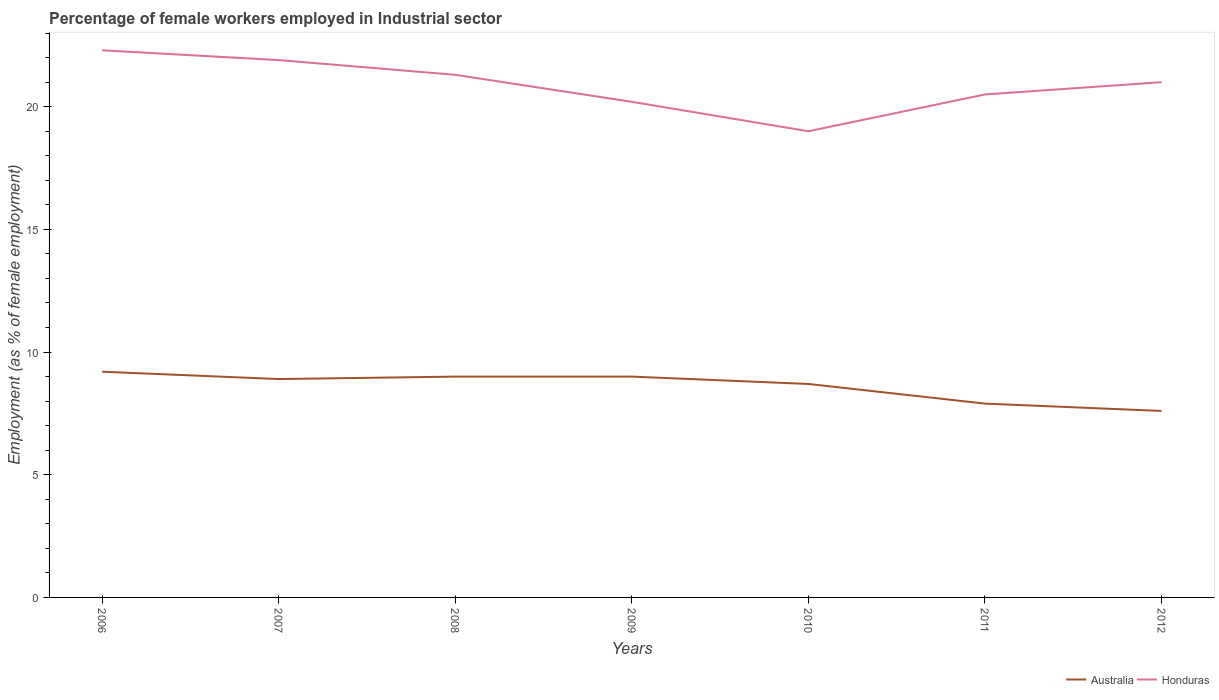How many different coloured lines are there?
Your response must be concise. 2. Across all years, what is the maximum percentage of females employed in Industrial sector in Honduras?
Offer a very short reply. 19. What is the total percentage of females employed in Industrial sector in Australia in the graph?
Keep it short and to the point. 0.2. What is the difference between the highest and the second highest percentage of females employed in Industrial sector in Australia?
Provide a succinct answer. 1.6. What is the difference between the highest and the lowest percentage of females employed in Industrial sector in Australia?
Keep it short and to the point. 5. Is the percentage of females employed in Industrial sector in Honduras strictly greater than the percentage of females employed in Industrial sector in Australia over the years?
Your response must be concise. No. Are the values on the major ticks of Y-axis written in scientific E-notation?
Make the answer very short. No. Does the graph contain any zero values?
Your answer should be compact. No. How many legend labels are there?
Your answer should be compact. 2. How are the legend labels stacked?
Provide a succinct answer. Horizontal. What is the title of the graph?
Offer a terse response. Percentage of female workers employed in Industrial sector. Does "Lithuania" appear as one of the legend labels in the graph?
Ensure brevity in your answer.  No. What is the label or title of the Y-axis?
Provide a short and direct response. Employment (as % of female employment). What is the Employment (as % of female employment) in Australia in 2006?
Keep it short and to the point. 9.2. What is the Employment (as % of female employment) in Honduras in 2006?
Give a very brief answer. 22.3. What is the Employment (as % of female employment) in Australia in 2007?
Offer a terse response. 8.9. What is the Employment (as % of female employment) in Honduras in 2007?
Make the answer very short. 21.9. What is the Employment (as % of female employment) of Australia in 2008?
Make the answer very short. 9. What is the Employment (as % of female employment) in Honduras in 2008?
Keep it short and to the point. 21.3. What is the Employment (as % of female employment) in Australia in 2009?
Ensure brevity in your answer.  9. What is the Employment (as % of female employment) in Honduras in 2009?
Ensure brevity in your answer.  20.2. What is the Employment (as % of female employment) of Australia in 2010?
Give a very brief answer. 8.7. What is the Employment (as % of female employment) of Australia in 2011?
Your answer should be compact. 7.9. What is the Employment (as % of female employment) of Australia in 2012?
Offer a terse response. 7.6. Across all years, what is the maximum Employment (as % of female employment) of Australia?
Your answer should be compact. 9.2. Across all years, what is the maximum Employment (as % of female employment) in Honduras?
Make the answer very short. 22.3. Across all years, what is the minimum Employment (as % of female employment) in Australia?
Your answer should be very brief. 7.6. What is the total Employment (as % of female employment) of Australia in the graph?
Offer a very short reply. 60.3. What is the total Employment (as % of female employment) in Honduras in the graph?
Your answer should be compact. 146.2. What is the difference between the Employment (as % of female employment) of Australia in 2006 and that in 2007?
Provide a short and direct response. 0.3. What is the difference between the Employment (as % of female employment) in Honduras in 2006 and that in 2007?
Ensure brevity in your answer.  0.4. What is the difference between the Employment (as % of female employment) of Australia in 2006 and that in 2008?
Make the answer very short. 0.2. What is the difference between the Employment (as % of female employment) in Australia in 2006 and that in 2009?
Keep it short and to the point. 0.2. What is the difference between the Employment (as % of female employment) in Honduras in 2006 and that in 2009?
Make the answer very short. 2.1. What is the difference between the Employment (as % of female employment) of Honduras in 2006 and that in 2010?
Provide a short and direct response. 3.3. What is the difference between the Employment (as % of female employment) of Australia in 2006 and that in 2011?
Provide a short and direct response. 1.3. What is the difference between the Employment (as % of female employment) in Honduras in 2006 and that in 2011?
Offer a terse response. 1.8. What is the difference between the Employment (as % of female employment) in Australia in 2006 and that in 2012?
Make the answer very short. 1.6. What is the difference between the Employment (as % of female employment) of Honduras in 2006 and that in 2012?
Offer a very short reply. 1.3. What is the difference between the Employment (as % of female employment) of Honduras in 2007 and that in 2008?
Give a very brief answer. 0.6. What is the difference between the Employment (as % of female employment) in Australia in 2007 and that in 2009?
Ensure brevity in your answer.  -0.1. What is the difference between the Employment (as % of female employment) in Australia in 2007 and that in 2010?
Your answer should be very brief. 0.2. What is the difference between the Employment (as % of female employment) of Honduras in 2007 and that in 2010?
Your answer should be compact. 2.9. What is the difference between the Employment (as % of female employment) in Australia in 2007 and that in 2011?
Provide a short and direct response. 1. What is the difference between the Employment (as % of female employment) in Australia in 2007 and that in 2012?
Ensure brevity in your answer.  1.3. What is the difference between the Employment (as % of female employment) of Honduras in 2007 and that in 2012?
Ensure brevity in your answer.  0.9. What is the difference between the Employment (as % of female employment) in Honduras in 2008 and that in 2010?
Provide a succinct answer. 2.3. What is the difference between the Employment (as % of female employment) of Australia in 2008 and that in 2012?
Your answer should be very brief. 1.4. What is the difference between the Employment (as % of female employment) in Honduras in 2009 and that in 2011?
Provide a short and direct response. -0.3. What is the difference between the Employment (as % of female employment) in Australia in 2009 and that in 2012?
Give a very brief answer. 1.4. What is the difference between the Employment (as % of female employment) of Honduras in 2010 and that in 2012?
Give a very brief answer. -2. What is the difference between the Employment (as % of female employment) in Honduras in 2011 and that in 2012?
Ensure brevity in your answer.  -0.5. What is the difference between the Employment (as % of female employment) of Australia in 2006 and the Employment (as % of female employment) of Honduras in 2007?
Your answer should be very brief. -12.7. What is the difference between the Employment (as % of female employment) of Australia in 2006 and the Employment (as % of female employment) of Honduras in 2008?
Give a very brief answer. -12.1. What is the difference between the Employment (as % of female employment) in Australia in 2006 and the Employment (as % of female employment) in Honduras in 2009?
Your answer should be compact. -11. What is the difference between the Employment (as % of female employment) in Australia in 2006 and the Employment (as % of female employment) in Honduras in 2011?
Keep it short and to the point. -11.3. What is the difference between the Employment (as % of female employment) of Australia in 2006 and the Employment (as % of female employment) of Honduras in 2012?
Keep it short and to the point. -11.8. What is the difference between the Employment (as % of female employment) of Australia in 2007 and the Employment (as % of female employment) of Honduras in 2010?
Offer a very short reply. -10.1. What is the difference between the Employment (as % of female employment) in Australia in 2007 and the Employment (as % of female employment) in Honduras in 2012?
Ensure brevity in your answer.  -12.1. What is the difference between the Employment (as % of female employment) in Australia in 2008 and the Employment (as % of female employment) in Honduras in 2009?
Keep it short and to the point. -11.2. What is the difference between the Employment (as % of female employment) in Australia in 2008 and the Employment (as % of female employment) in Honduras in 2010?
Keep it short and to the point. -10. What is the difference between the Employment (as % of female employment) of Australia in 2008 and the Employment (as % of female employment) of Honduras in 2012?
Offer a terse response. -12. What is the difference between the Employment (as % of female employment) in Australia in 2009 and the Employment (as % of female employment) in Honduras in 2010?
Keep it short and to the point. -10. What is the difference between the Employment (as % of female employment) in Australia in 2009 and the Employment (as % of female employment) in Honduras in 2012?
Ensure brevity in your answer.  -12. What is the difference between the Employment (as % of female employment) of Australia in 2010 and the Employment (as % of female employment) of Honduras in 2011?
Your answer should be compact. -11.8. What is the difference between the Employment (as % of female employment) of Australia in 2010 and the Employment (as % of female employment) of Honduras in 2012?
Keep it short and to the point. -12.3. What is the difference between the Employment (as % of female employment) in Australia in 2011 and the Employment (as % of female employment) in Honduras in 2012?
Your response must be concise. -13.1. What is the average Employment (as % of female employment) of Australia per year?
Offer a very short reply. 8.61. What is the average Employment (as % of female employment) in Honduras per year?
Provide a succinct answer. 20.89. In the year 2008, what is the difference between the Employment (as % of female employment) in Australia and Employment (as % of female employment) in Honduras?
Offer a very short reply. -12.3. In the year 2009, what is the difference between the Employment (as % of female employment) in Australia and Employment (as % of female employment) in Honduras?
Offer a terse response. -11.2. In the year 2010, what is the difference between the Employment (as % of female employment) in Australia and Employment (as % of female employment) in Honduras?
Give a very brief answer. -10.3. What is the ratio of the Employment (as % of female employment) of Australia in 2006 to that in 2007?
Make the answer very short. 1.03. What is the ratio of the Employment (as % of female employment) in Honduras in 2006 to that in 2007?
Your answer should be very brief. 1.02. What is the ratio of the Employment (as % of female employment) of Australia in 2006 to that in 2008?
Keep it short and to the point. 1.02. What is the ratio of the Employment (as % of female employment) of Honduras in 2006 to that in 2008?
Make the answer very short. 1.05. What is the ratio of the Employment (as % of female employment) of Australia in 2006 to that in 2009?
Keep it short and to the point. 1.02. What is the ratio of the Employment (as % of female employment) of Honduras in 2006 to that in 2009?
Offer a very short reply. 1.1. What is the ratio of the Employment (as % of female employment) of Australia in 2006 to that in 2010?
Give a very brief answer. 1.06. What is the ratio of the Employment (as % of female employment) of Honduras in 2006 to that in 2010?
Make the answer very short. 1.17. What is the ratio of the Employment (as % of female employment) of Australia in 2006 to that in 2011?
Provide a succinct answer. 1.16. What is the ratio of the Employment (as % of female employment) of Honduras in 2006 to that in 2011?
Your answer should be very brief. 1.09. What is the ratio of the Employment (as % of female employment) of Australia in 2006 to that in 2012?
Offer a terse response. 1.21. What is the ratio of the Employment (as % of female employment) of Honduras in 2006 to that in 2012?
Ensure brevity in your answer.  1.06. What is the ratio of the Employment (as % of female employment) in Australia in 2007 to that in 2008?
Give a very brief answer. 0.99. What is the ratio of the Employment (as % of female employment) in Honduras in 2007 to that in 2008?
Your response must be concise. 1.03. What is the ratio of the Employment (as % of female employment) of Australia in 2007 to that in 2009?
Your answer should be very brief. 0.99. What is the ratio of the Employment (as % of female employment) in Honduras in 2007 to that in 2009?
Ensure brevity in your answer.  1.08. What is the ratio of the Employment (as % of female employment) of Australia in 2007 to that in 2010?
Provide a short and direct response. 1.02. What is the ratio of the Employment (as % of female employment) of Honduras in 2007 to that in 2010?
Provide a succinct answer. 1.15. What is the ratio of the Employment (as % of female employment) in Australia in 2007 to that in 2011?
Provide a succinct answer. 1.13. What is the ratio of the Employment (as % of female employment) in Honduras in 2007 to that in 2011?
Your answer should be very brief. 1.07. What is the ratio of the Employment (as % of female employment) in Australia in 2007 to that in 2012?
Your answer should be compact. 1.17. What is the ratio of the Employment (as % of female employment) of Honduras in 2007 to that in 2012?
Give a very brief answer. 1.04. What is the ratio of the Employment (as % of female employment) of Honduras in 2008 to that in 2009?
Your answer should be compact. 1.05. What is the ratio of the Employment (as % of female employment) in Australia in 2008 to that in 2010?
Provide a succinct answer. 1.03. What is the ratio of the Employment (as % of female employment) in Honduras in 2008 to that in 2010?
Your response must be concise. 1.12. What is the ratio of the Employment (as % of female employment) in Australia in 2008 to that in 2011?
Keep it short and to the point. 1.14. What is the ratio of the Employment (as % of female employment) in Honduras in 2008 to that in 2011?
Your response must be concise. 1.04. What is the ratio of the Employment (as % of female employment) in Australia in 2008 to that in 2012?
Your answer should be compact. 1.18. What is the ratio of the Employment (as % of female employment) in Honduras in 2008 to that in 2012?
Your response must be concise. 1.01. What is the ratio of the Employment (as % of female employment) in Australia in 2009 to that in 2010?
Offer a very short reply. 1.03. What is the ratio of the Employment (as % of female employment) in Honduras in 2009 to that in 2010?
Ensure brevity in your answer.  1.06. What is the ratio of the Employment (as % of female employment) of Australia in 2009 to that in 2011?
Offer a terse response. 1.14. What is the ratio of the Employment (as % of female employment) in Honduras in 2009 to that in 2011?
Keep it short and to the point. 0.99. What is the ratio of the Employment (as % of female employment) of Australia in 2009 to that in 2012?
Make the answer very short. 1.18. What is the ratio of the Employment (as % of female employment) in Honduras in 2009 to that in 2012?
Provide a short and direct response. 0.96. What is the ratio of the Employment (as % of female employment) in Australia in 2010 to that in 2011?
Make the answer very short. 1.1. What is the ratio of the Employment (as % of female employment) in Honduras in 2010 to that in 2011?
Your answer should be compact. 0.93. What is the ratio of the Employment (as % of female employment) in Australia in 2010 to that in 2012?
Offer a very short reply. 1.14. What is the ratio of the Employment (as % of female employment) of Honduras in 2010 to that in 2012?
Offer a terse response. 0.9. What is the ratio of the Employment (as % of female employment) in Australia in 2011 to that in 2012?
Your answer should be compact. 1.04. What is the ratio of the Employment (as % of female employment) in Honduras in 2011 to that in 2012?
Provide a short and direct response. 0.98. What is the difference between the highest and the second highest Employment (as % of female employment) in Australia?
Your response must be concise. 0.2. What is the difference between the highest and the lowest Employment (as % of female employment) of Australia?
Give a very brief answer. 1.6. What is the difference between the highest and the lowest Employment (as % of female employment) of Honduras?
Offer a very short reply. 3.3. 